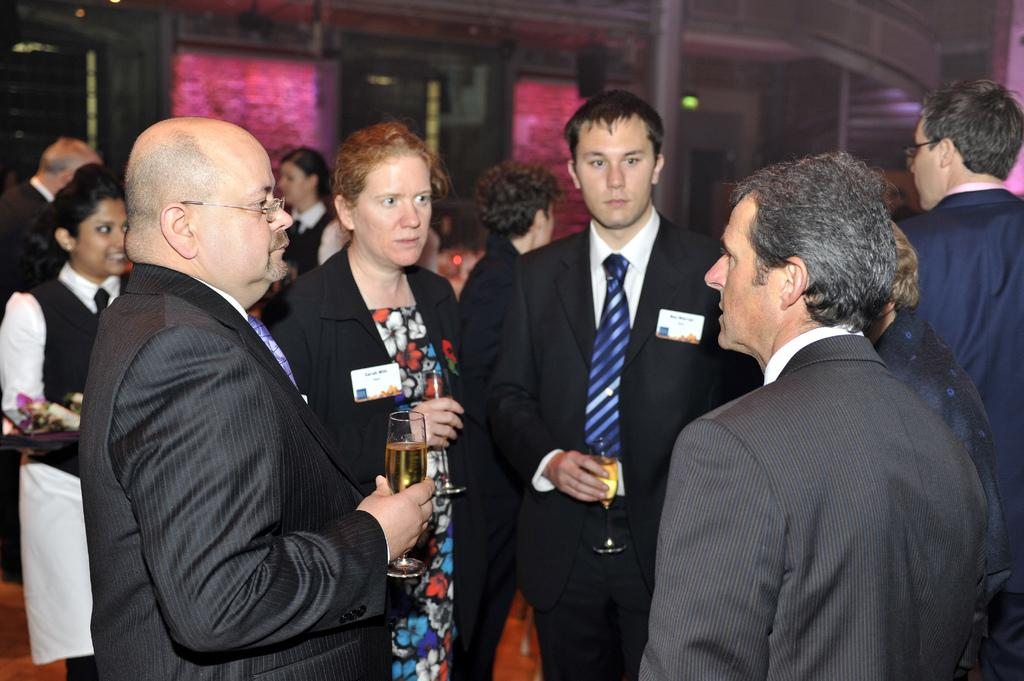What are the people in the image doing? The people in the image are standing. What are some of the people holding? Some people are holding drinks. What can be seen in the background behind the people? There are pink color boards, a pillar, and lights visible in the background. Are there any trees visible in the image? No, there are no trees visible in the image. Can you describe how the people are jumping in the image? There is no jumping activity depicted in the image; the people are standing. 